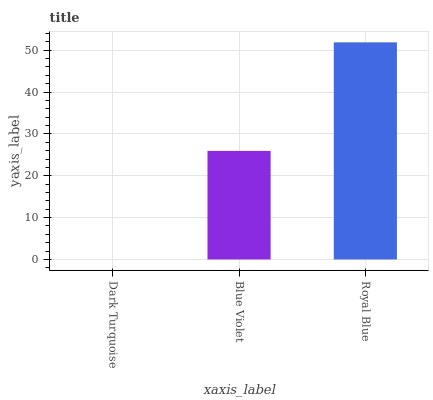Is Dark Turquoise the minimum?
Answer yes or no. Yes. Is Royal Blue the maximum?
Answer yes or no. Yes. Is Blue Violet the minimum?
Answer yes or no. No. Is Blue Violet the maximum?
Answer yes or no. No. Is Blue Violet greater than Dark Turquoise?
Answer yes or no. Yes. Is Dark Turquoise less than Blue Violet?
Answer yes or no. Yes. Is Dark Turquoise greater than Blue Violet?
Answer yes or no. No. Is Blue Violet less than Dark Turquoise?
Answer yes or no. No. Is Blue Violet the high median?
Answer yes or no. Yes. Is Blue Violet the low median?
Answer yes or no. Yes. Is Dark Turquoise the high median?
Answer yes or no. No. Is Royal Blue the low median?
Answer yes or no. No. 